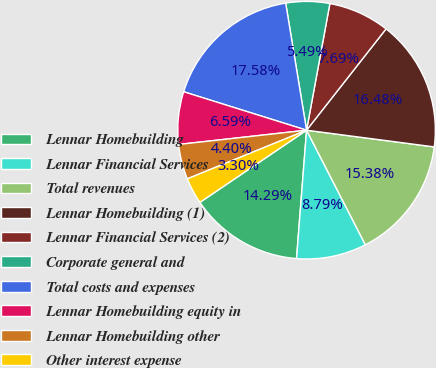Convert chart to OTSL. <chart><loc_0><loc_0><loc_500><loc_500><pie_chart><fcel>Lennar Homebuilding<fcel>Lennar Financial Services<fcel>Total revenues<fcel>Lennar Homebuilding (1)<fcel>Lennar Financial Services (2)<fcel>Corporate general and<fcel>Total costs and expenses<fcel>Lennar Homebuilding equity in<fcel>Lennar Homebuilding other<fcel>Other interest expense<nl><fcel>14.29%<fcel>8.79%<fcel>15.38%<fcel>16.48%<fcel>7.69%<fcel>5.49%<fcel>17.58%<fcel>6.59%<fcel>4.4%<fcel>3.3%<nl></chart> 